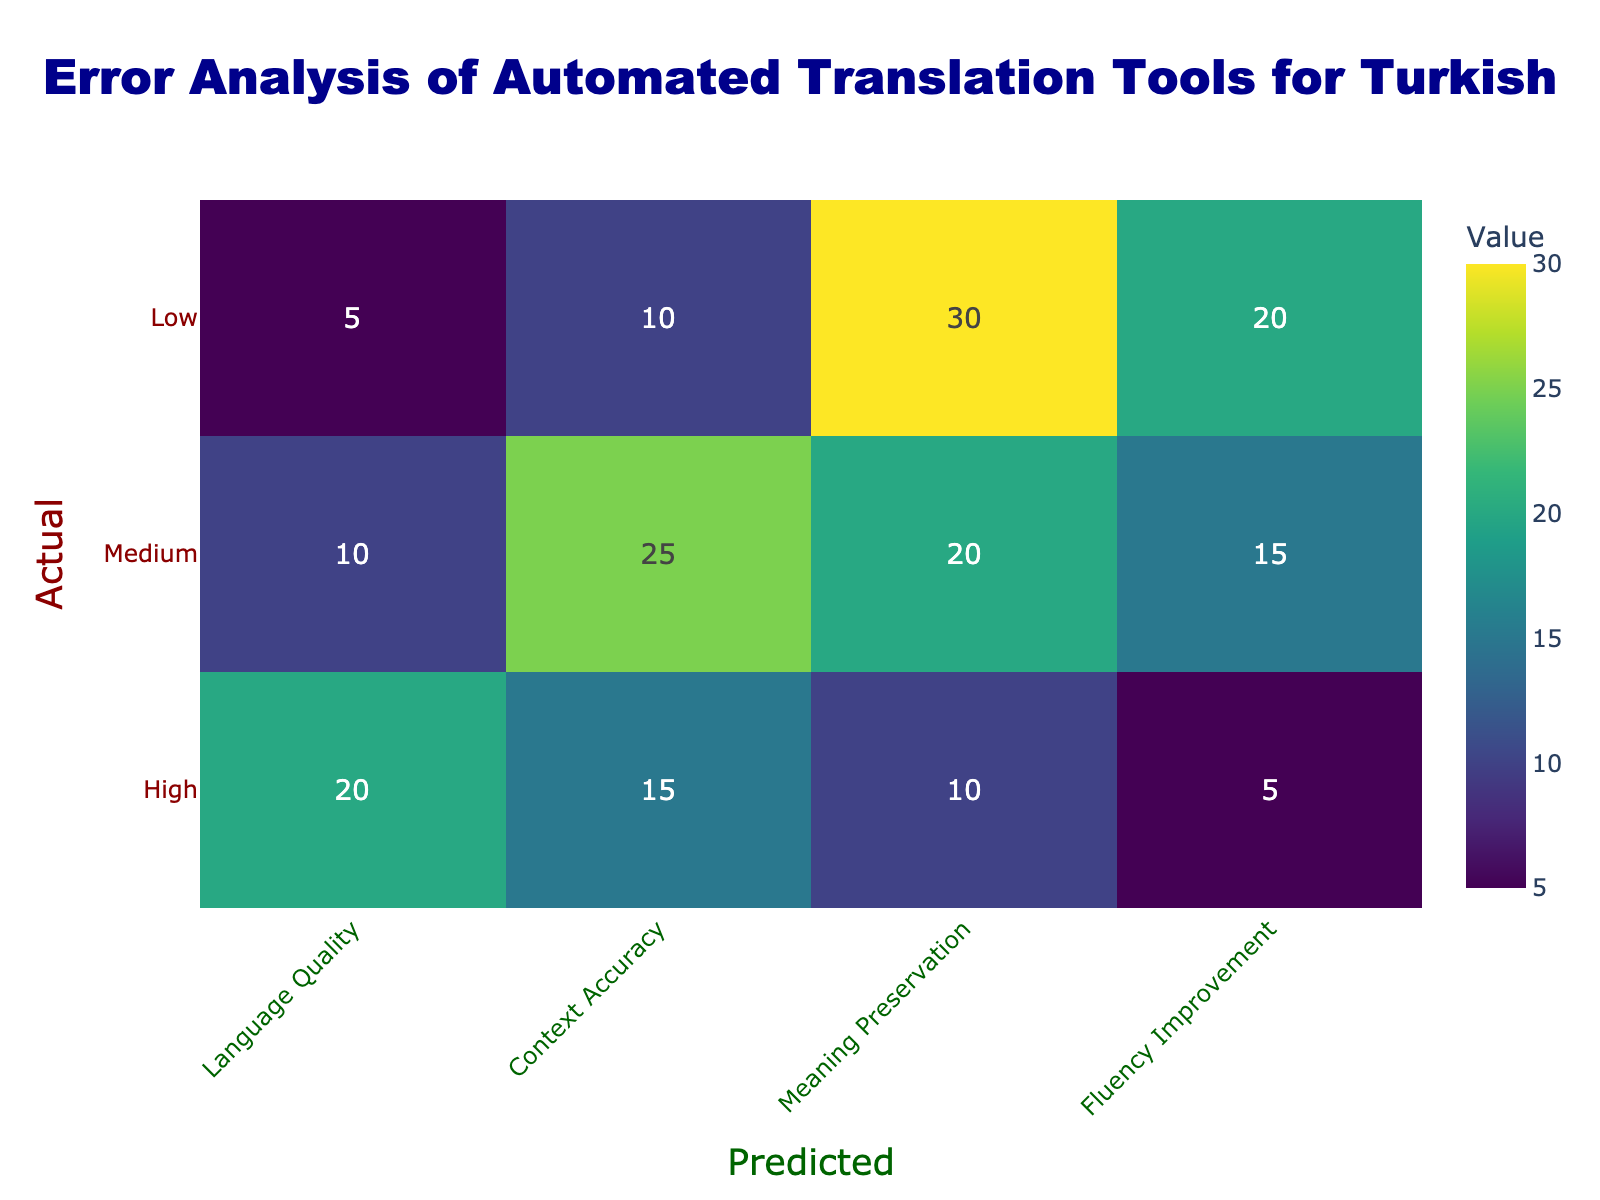What is the number of instances where the actual translation quality was rated as high and predicted to be medium for language quality? Referring to the table, in the "High" row under "Language Quality," we look for the predicted value of "Medium." The value in that cell is 10.
Answer: 10 What is the total number of instances where the actual translation quality was rated as low? To find this, we sum up the values in the "Low" row: (5 + 10 + 30 + 20) = 65.
Answer: 65 Is there any instance where the actual translation quality was both rated low and predicted to be high? Looking at the table in the "Low" row and "High" column, the value is 5, indicating that there were instances where the actual was low and predicted high, thus the answer is yes.
Answer: Yes What is the highest predicted value across all actual ratings for context accuracy? We look at the "Context Accuracy" column and identify the highest value. The values are 15, 25, and 10 for high, medium, and low actual ratings, respectively. The maximum among these is 25.
Answer: 25 What is the average predicted value for meaning preservation when the actual quality is rated as medium? For the "Medium" row in the "Meaning Preservation" column, the value is 20. Since there's only one predicted value in this scenario, the average is simply 20.
Answer: 20 What is the total number of instances predicted as high across all actual quality ratings? We sum the values across the "High" column: (20 + 10 + 5) = 35.
Answer: 35 Is the predicted value for fluency improvement higher when actual quality is rated high than when it is rated medium? In the "Fluency Improvement" column, the value for the actual quality rated as high is 5, and for medium, it is 15. Since 5 is not higher than 15, the answer is no.
Answer: No How many more instances are predicted as low than medium for fluency improvement? In the "Fluency Improvement" column, we take the low value of 20 and the medium value of 15. The difference: 20 - 15 = 5, indicating more instances predicted as low.
Answer: 5 What is the relationship between the predicted values of high and low actual quality concerning language quality? By comparing high (20) and low (5) values under the "Language Quality," it shows that there are significantly more instances predicted to be high than low. The relationship indicates a stronger alignment or performance at higher predicted values.
Answer: Higher predicted for high than low 